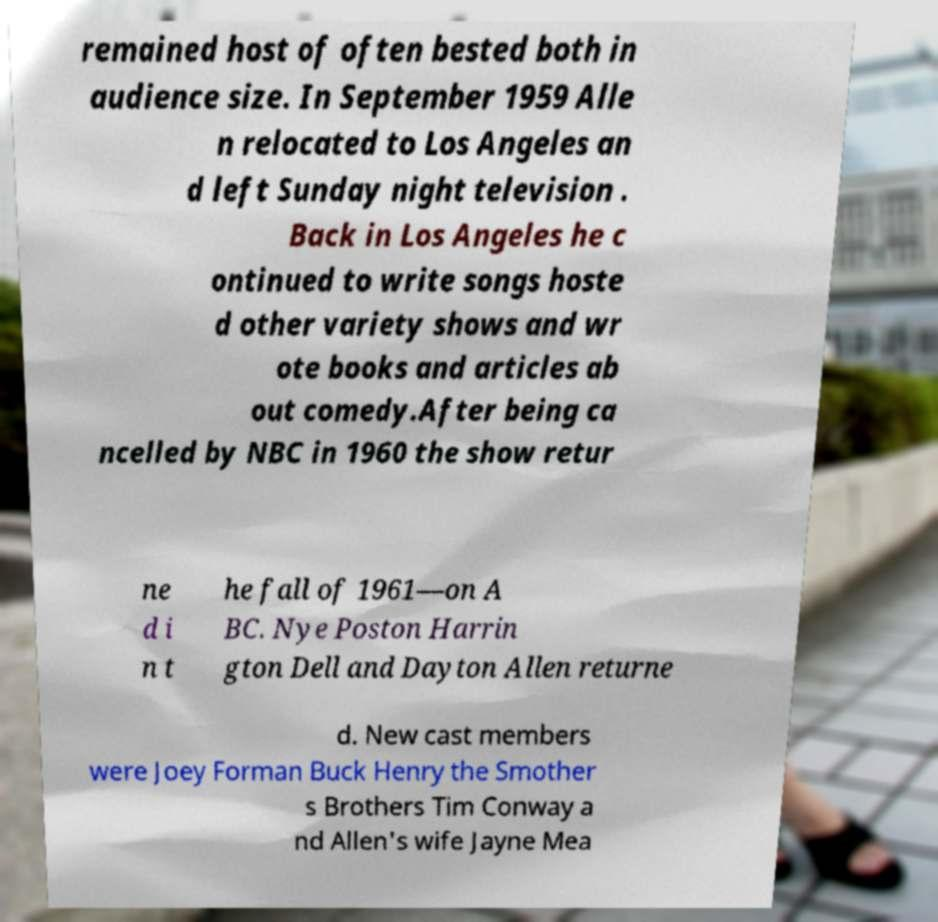Could you extract and type out the text from this image? remained host of often bested both in audience size. In September 1959 Alle n relocated to Los Angeles an d left Sunday night television . Back in Los Angeles he c ontinued to write songs hoste d other variety shows and wr ote books and articles ab out comedy.After being ca ncelled by NBC in 1960 the show retur ne d i n t he fall of 1961—on A BC. Nye Poston Harrin gton Dell and Dayton Allen returne d. New cast members were Joey Forman Buck Henry the Smother s Brothers Tim Conway a nd Allen's wife Jayne Mea 